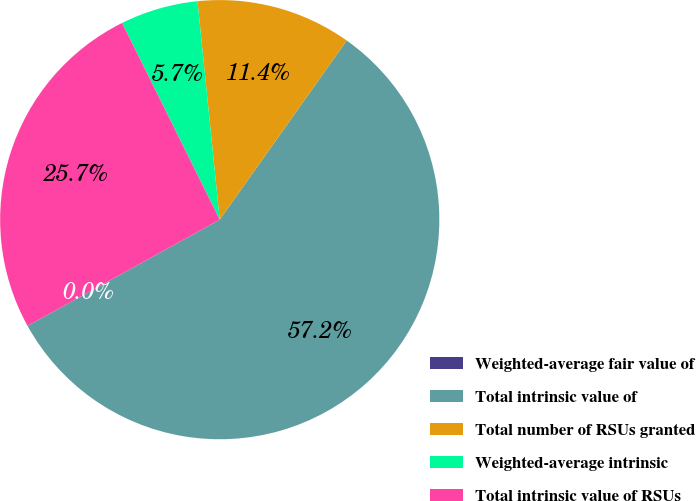Convert chart to OTSL. <chart><loc_0><loc_0><loc_500><loc_500><pie_chart><fcel>Weighted-average fair value of<fcel>Total intrinsic value of<fcel>Total number of RSUs granted<fcel>Weighted-average intrinsic<fcel>Total intrinsic value of RSUs<nl><fcel>0.0%<fcel>57.15%<fcel>11.43%<fcel>5.72%<fcel>25.7%<nl></chart> 